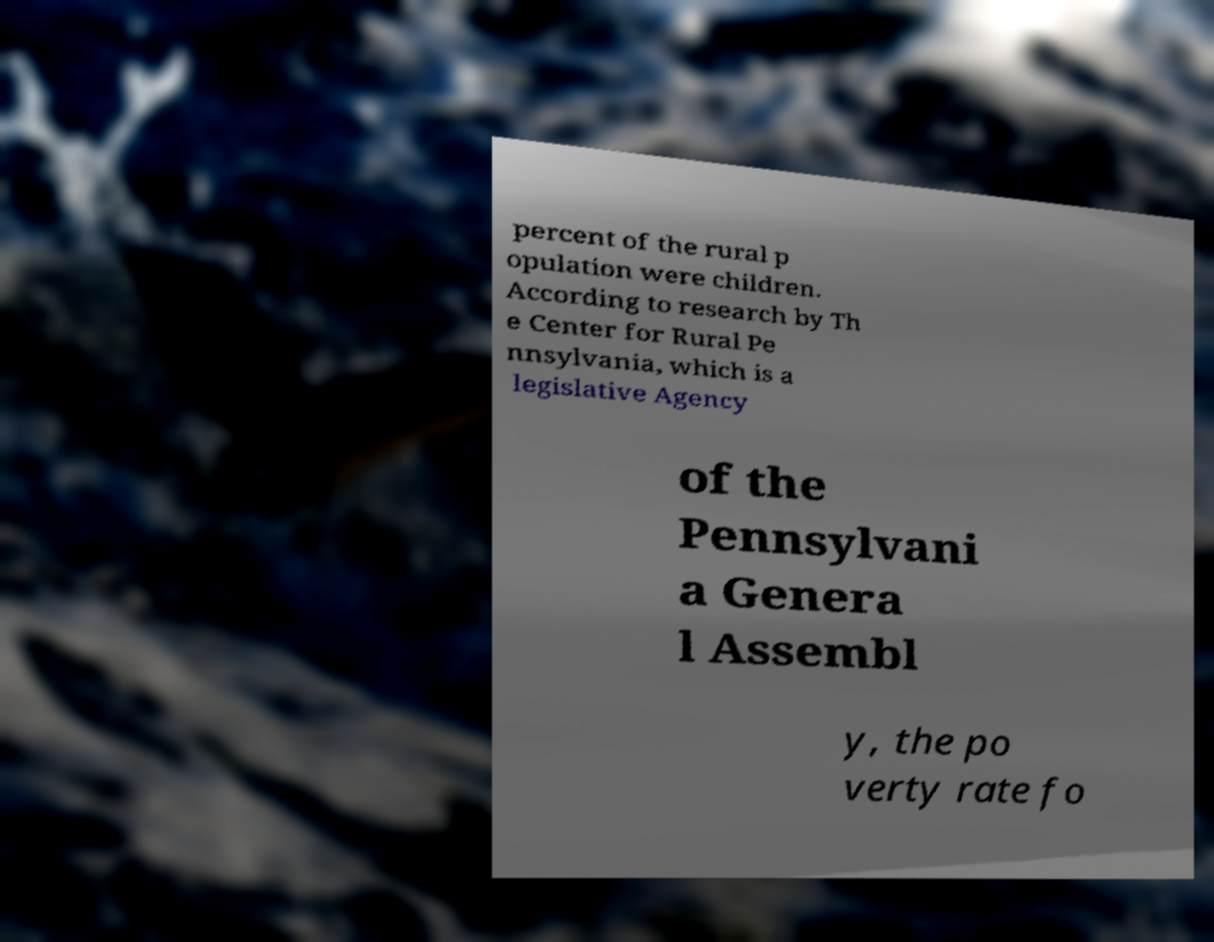Please identify and transcribe the text found in this image. percent of the rural p opulation were children. According to research by Th e Center for Rural Pe nnsylvania, which is a legislative Agency of the Pennsylvani a Genera l Assembl y, the po verty rate fo 